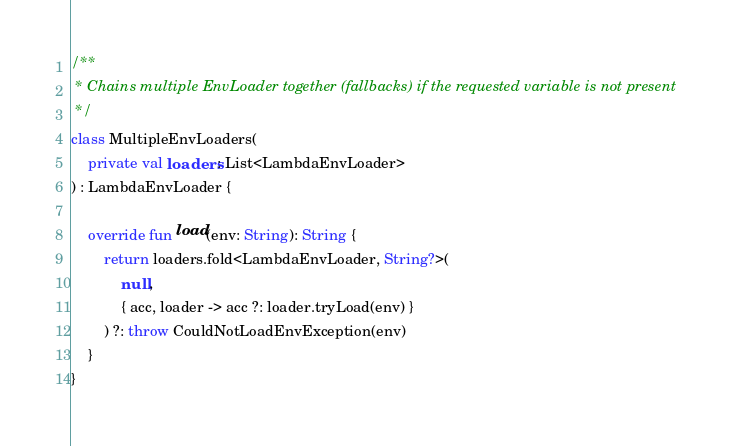<code> <loc_0><loc_0><loc_500><loc_500><_Kotlin_>
/**
 * Chains multiple EnvLoader together (fallbacks) if the requested variable is not present
 */
class MultipleEnvLoaders(
    private val loaders: List<LambdaEnvLoader>
) : LambdaEnvLoader {

    override fun load(env: String): String {
        return loaders.fold<LambdaEnvLoader, String?>(
            null,
            { acc, loader -> acc ?: loader.tryLoad(env) }
        ) ?: throw CouldNotLoadEnvException(env)
    }
}
</code> 